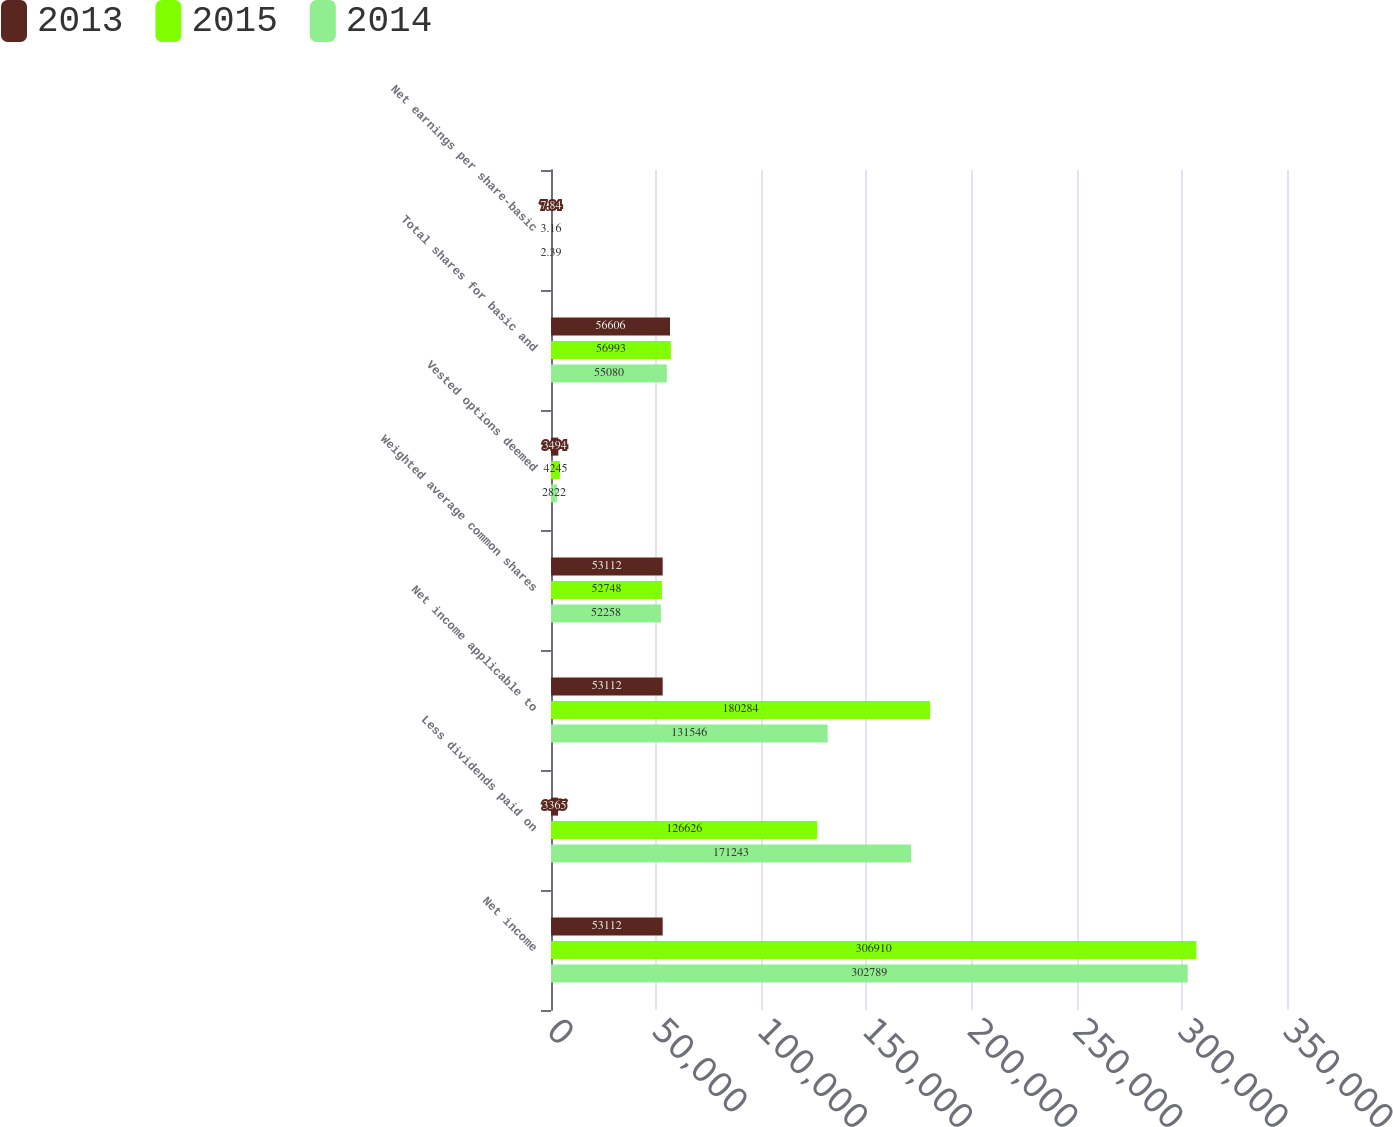Convert chart to OTSL. <chart><loc_0><loc_0><loc_500><loc_500><stacked_bar_chart><ecel><fcel>Net income<fcel>Less dividends paid on<fcel>Net income applicable to<fcel>Weighted average common shares<fcel>Vested options deemed<fcel>Total shares for basic and<fcel>Net earnings per share-basic<nl><fcel>2013<fcel>53112<fcel>3365<fcel>53112<fcel>53112<fcel>3494<fcel>56606<fcel>7.84<nl><fcel>2015<fcel>306910<fcel>126626<fcel>180284<fcel>52748<fcel>4245<fcel>56993<fcel>3.16<nl><fcel>2014<fcel>302789<fcel>171243<fcel>131546<fcel>52258<fcel>2822<fcel>55080<fcel>2.39<nl></chart> 